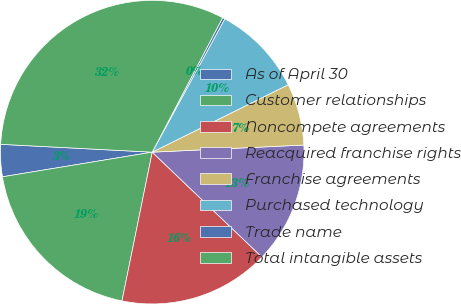Convert chart to OTSL. <chart><loc_0><loc_0><loc_500><loc_500><pie_chart><fcel>As of April 30<fcel>Customer relationships<fcel>Noncompete agreements<fcel>Reacquired franchise rights<fcel>Franchise agreements<fcel>Purchased technology<fcel>Trade name<fcel>Total intangible assets<nl><fcel>3.42%<fcel>19.21%<fcel>16.05%<fcel>12.89%<fcel>6.58%<fcel>9.74%<fcel>0.26%<fcel>31.85%<nl></chart> 